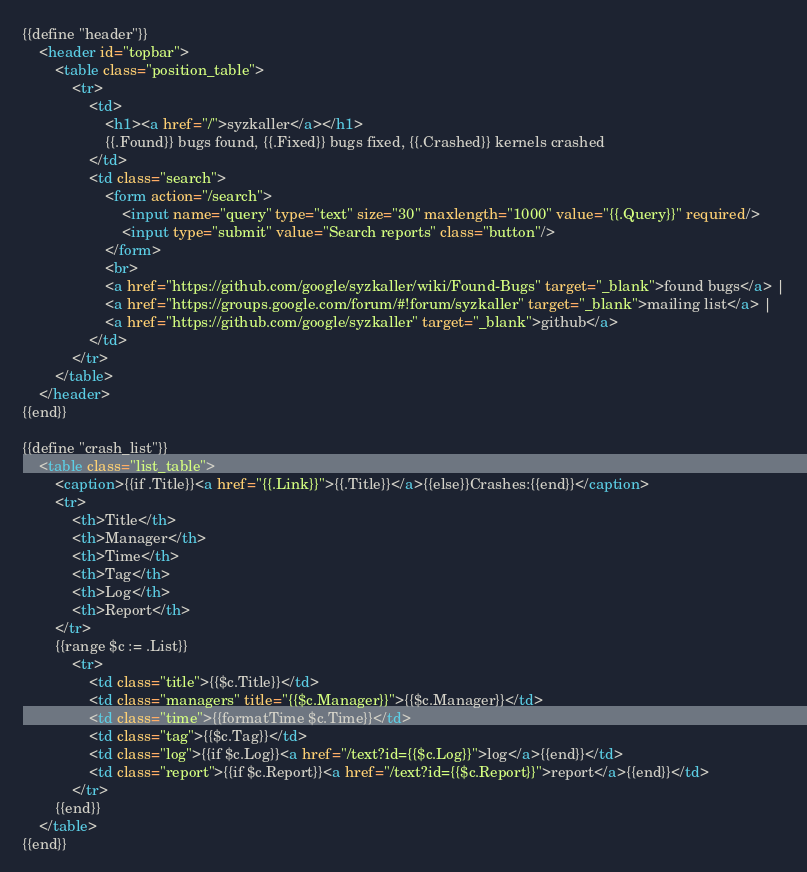Convert code to text. <code><loc_0><loc_0><loc_500><loc_500><_HTML_>{{define "header"}}
	<header id="topbar">
		<table class="position_table">
			<tr>
				<td>
					<h1><a href="/">syzkaller</a></h1>
					{{.Found}} bugs found, {{.Fixed}} bugs fixed, {{.Crashed}} kernels crashed
				</td>
				<td class="search">
					<form action="/search">
						<input name="query" type="text" size="30" maxlength="1000" value="{{.Query}}" required/>
						<input type="submit" value="Search reports" class="button"/>
					</form>
					<br>
					<a href="https://github.com/google/syzkaller/wiki/Found-Bugs" target="_blank">found bugs</a> |
					<a href="https://groups.google.com/forum/#!forum/syzkaller" target="_blank">mailing list</a> |
					<a href="https://github.com/google/syzkaller" target="_blank">github</a>
				</td>
			</tr>
		</table>
	</header>
{{end}}

{{define "crash_list"}}
	<table class="list_table">
		<caption>{{if .Title}}<a href="{{.Link}}">{{.Title}}</a>{{else}}Crashes:{{end}}</caption>
		<tr>
			<th>Title</th>
			<th>Manager</th>
			<th>Time</th>
			<th>Tag</th>
			<th>Log</th>
			<th>Report</th>
		</tr>
		{{range $c := .List}}
			<tr>
				<td class="title">{{$c.Title}}</td>
				<td class="managers" title="{{$c.Manager}}">{{$c.Manager}}</td>
				<td class="time">{{formatTime $c.Time}}</td>
				<td class="tag">{{$c.Tag}}</td>
				<td class="log">{{if $c.Log}}<a href="/text?id={{$c.Log}}">log</a>{{end}}</td>
				<td class="report">{{if $c.Report}}<a href="/text?id={{$c.Report}}">report</a>{{end}}</td>
			</tr>
		{{end}}
	</table>
{{end}}
</code> 